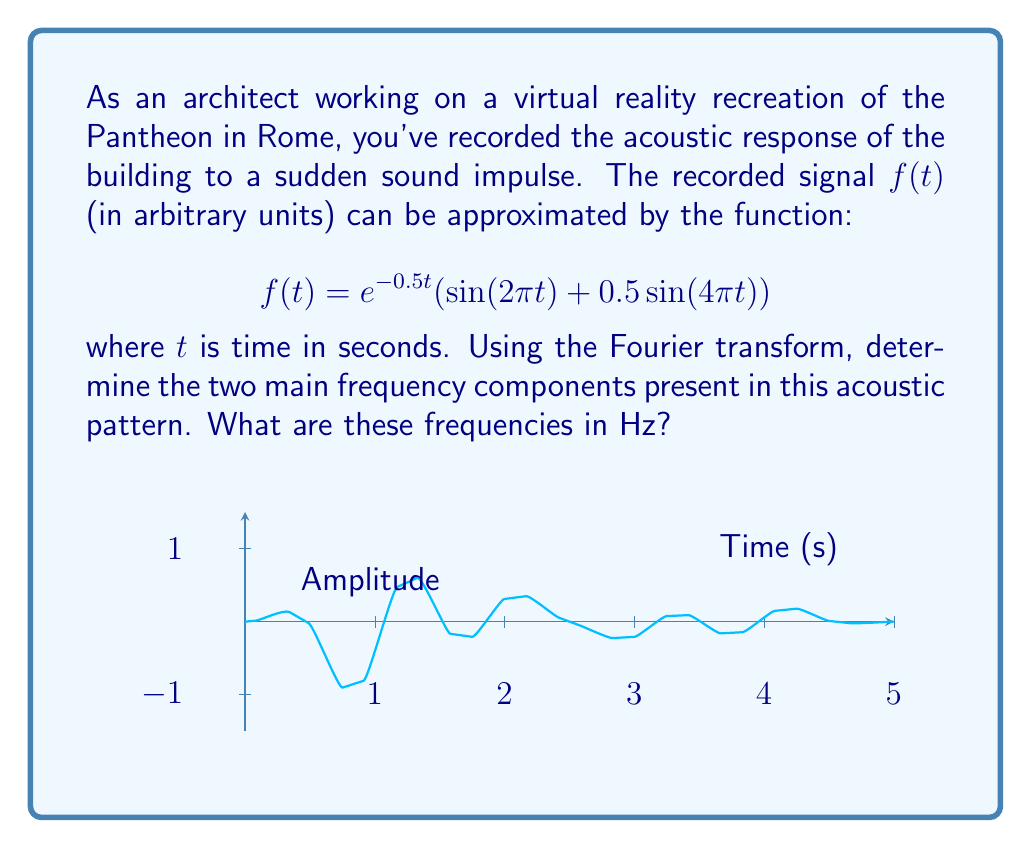Teach me how to tackle this problem. To find the frequency components, we need to analyze the given function:

$$f(t) = e^{-0.5t}(\sin(2\pi t) + 0.5\sin(4\pi t))$$

1) The exponential term $e^{-0.5t}$ represents the decay of the sound over time and doesn't contribute to the frequency content.

2) The sinusoidal terms contain the frequency information:
   
   a) $\sin(2\pi t)$: The argument of sine is $2\pi t$
   b) $0.5\sin(4\pi t)$: The argument of sine is $4\pi t$

3) For a sinusoidal function $\sin(2\pi ft)$, the frequency $f$ is given by the coefficient of $t$ divided by $2\pi$.

4) For the first term:
   Frequency $f_1 = \frac{2\pi}{2\pi} = 1$ Hz

5) For the second term:
   Frequency $f_2 = \frac{4\pi}{2\pi} = 2$ Hz

Therefore, the two main frequency components are 1 Hz and 2 Hz.
Answer: 1 Hz and 2 Hz 